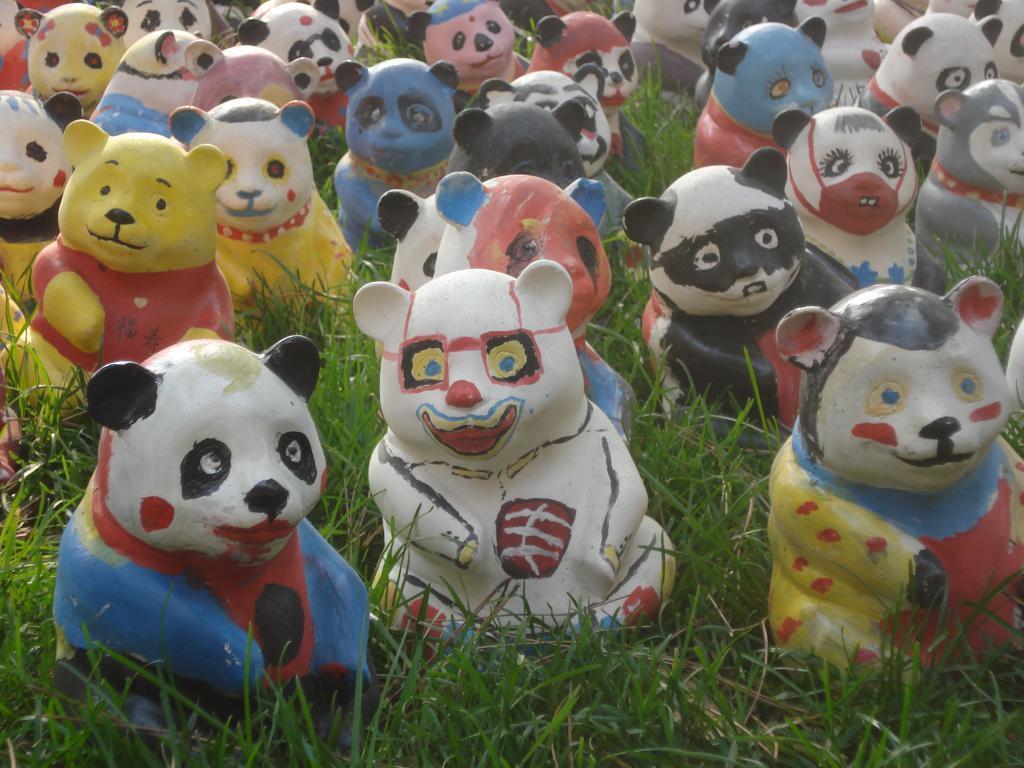Describe this image in one or two sentences. In this picture we can see different colors toys. On the bottom we can see grass. 